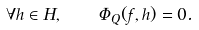Convert formula to latex. <formula><loc_0><loc_0><loc_500><loc_500>\forall h \in H , \quad \Phi _ { Q } ( f , h ) = 0 .</formula> 